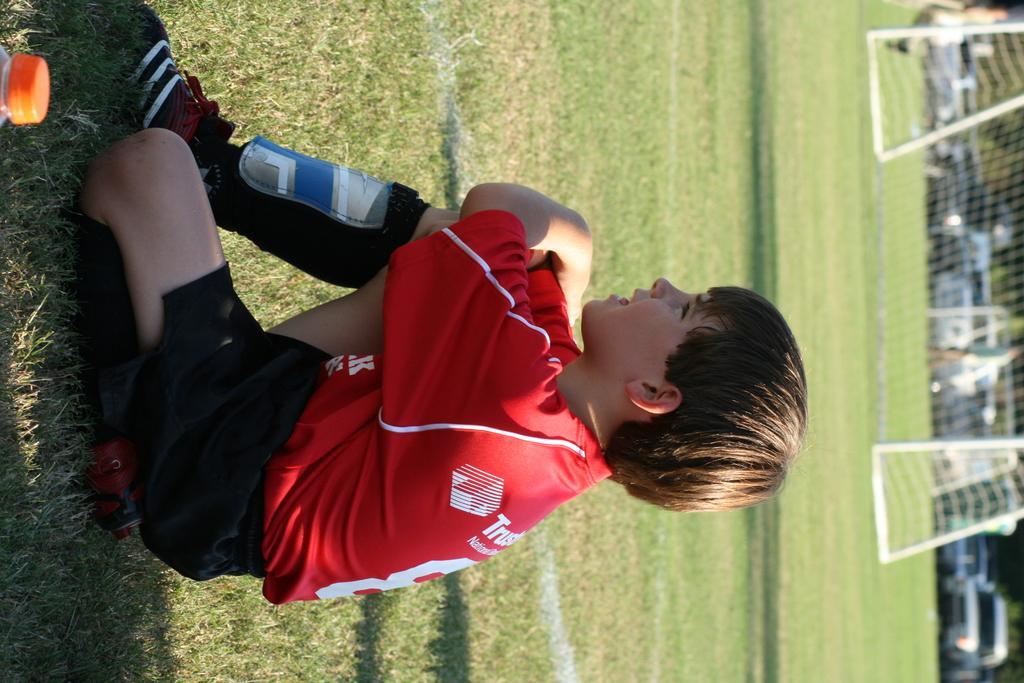Can you describe this image briefly? Here we can see a boy is sitting on the ground and on the left we can see a truncated bottle. In the background there is a goal net,poles,few persons,vehicles and trees. 